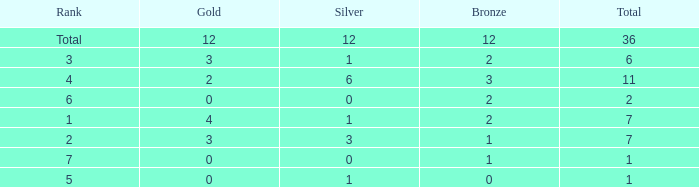What is the number of bronze medals when there are fewer than 0 silver medals? None. 